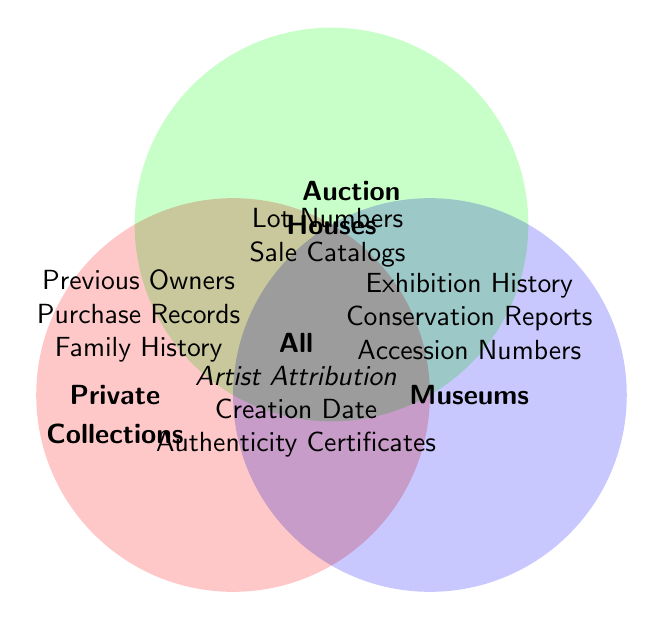What elements are shared by all three categories (Private Collections, Auction Houses, and Museums)? The shared elements are indicated in the overlapping middle section of the Venn diagram. These are elements that fall within the intersection of all the circles. They include "Artist Attribution", "Creation Date", and "Authenticity Certificates".
Answer: Artist Attribution, Creation Date, Authenticity Certificates Which element is common between Private Collections and Auction Houses but not Museums? To find the element common between Private Collections and Auction Houses but not Museums, look for elements in the intersecting area of these two circles excluding the area covered by Museums. It's "Previous Owners".
Answer: Previous Owners How many specific elements does each category (Private Collections, Auction Houses, and Museums) have that are not shared with others? For each of the circles exclusively, count the unique elements: Private Collections has "Purchase Records" and "Family History"; Auction Houses has "Lot Numbers" and "Sale Catalogs"; Museums has "Exhibition History", "Conservation Reports", and "Accession Numbers". This means Private Collections have 2, Auction Houses have 2, and Museums have 3 unique elements.
Answer: Private Collections: 2, Auction Houses: 2, Museums: 3 Are there elements that are common in Auction Houses and Museums but not in Private Collections? To identify these, find the overlapping part of Auction Houses and Museums circles excluding the Private Collections circle. There are no such elements defined in the figure.
Answer: No Which category has the most unique elements and what are they? Count the unique elements for each category: Private Collections (2 unique elements), Auction Houses (2 unique elements), Museums (3 unique elements). Museums have the most unique elements: "Exhibition History", "Conservation Reports", and "Accession Numbers".
Answer: Museums: Exhibition History, Conservation Reports, Accession Numbers How many categories include the element "Previous Owners"? Count the circles that overlap the given element "Previous Owners". It falls under Private Collections and Auction Houses.
Answer: 2 categories (Private Collections and Auction Houses) What is the total number of unique elements listed in all categories excluding shared ones? Add up the unique elements specified in each category excluding those shared among various circles. Private Collections (2: Purchase Records, Family History), Auction Houses (2: Lot Numbers, Sale Catalogs), Museums (3: Exhibition History, Conservation Reports, Accession Numbers); total = 2 + 2 + 3 = 7 unique elements.
Answer: 7 elements Which elements fall under only Museums and not shared by any other category? These are the elements not overlapping with any other circles and exclusively in the Museums circle. They are "Exhibition History", "Conservation Reports", and "Accession Numbers".
Answer: Exhibition History, Conservation Reports, Accession Numbers How many types of provenance documentation elements are shared between two or more categories? Count the elements in overlapping sections, including intersections of all the circles and sections shared among pairs: "Previous Owners", "Artist Attribution", "Creation Date", "Authenticity Certificates". There are 4 overall.
Answer: 4 elements 